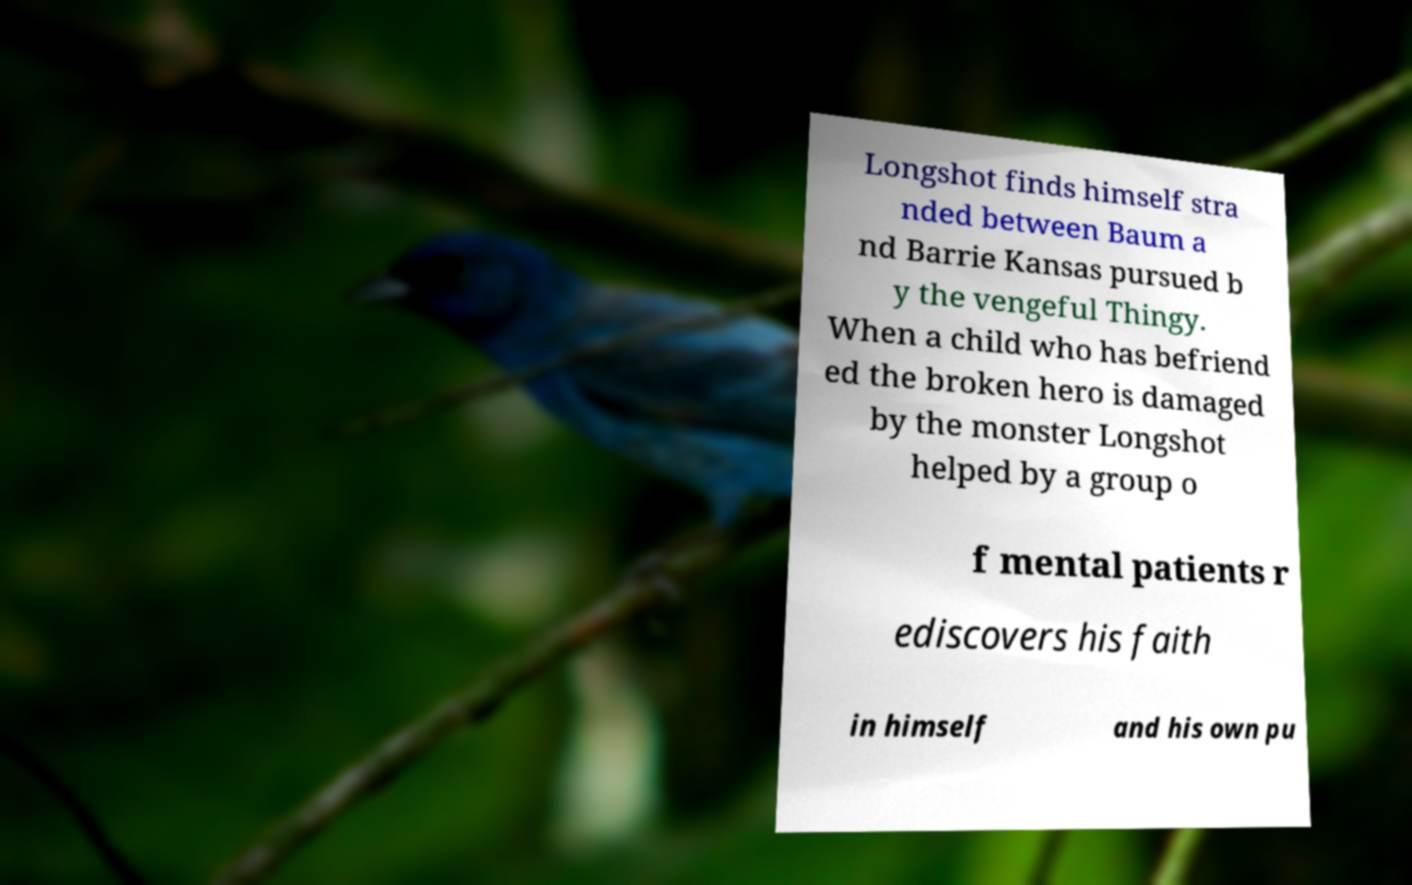Please identify and transcribe the text found in this image. Longshot finds himself stra nded between Baum a nd Barrie Kansas pursued b y the vengeful Thingy. When a child who has befriend ed the broken hero is damaged by the monster Longshot helped by a group o f mental patients r ediscovers his faith in himself and his own pu 